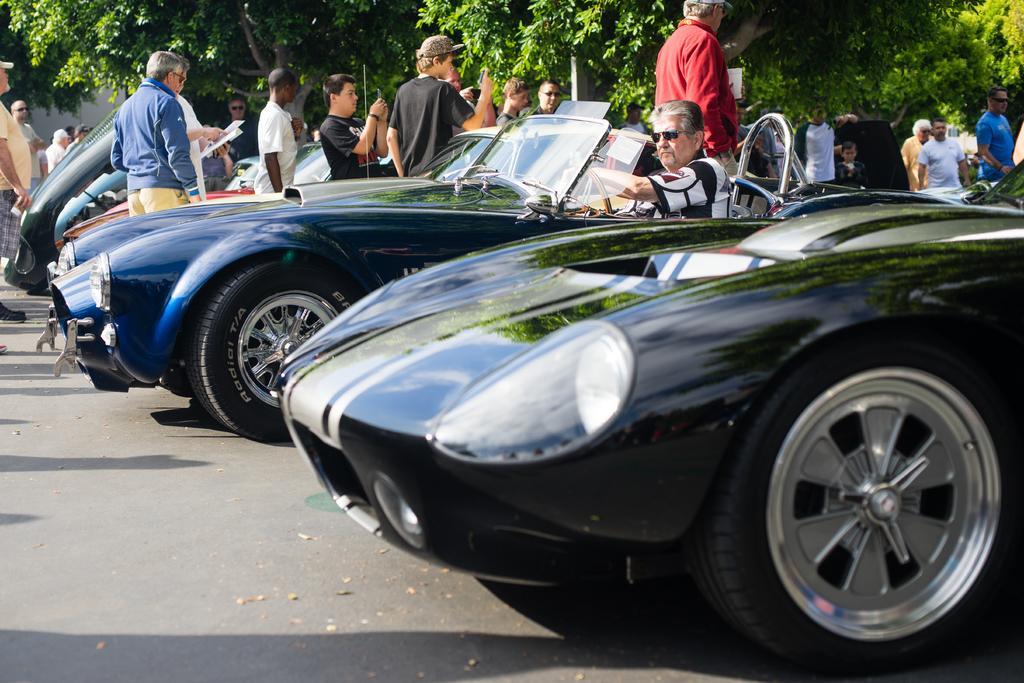Please provide a concise description of this image. In this image in the center there are cars on the road and there is a person sitting inside the car, and there are persons standing in the center. In the background there are trees. 